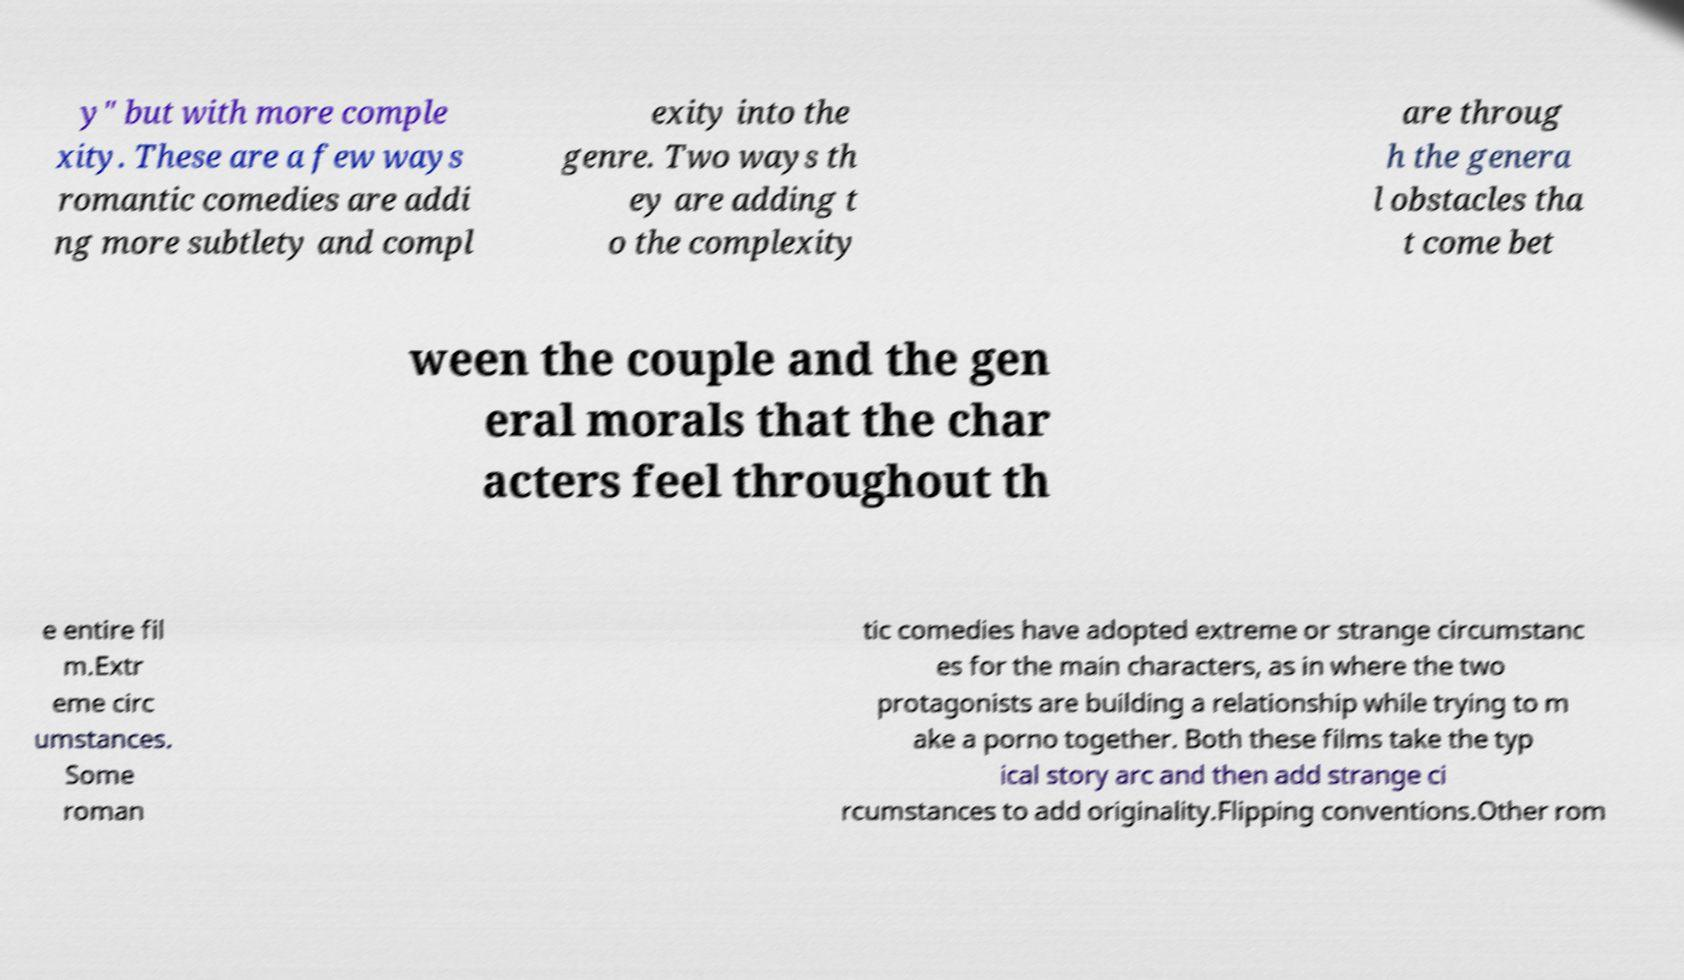Please identify and transcribe the text found in this image. y" but with more comple xity. These are a few ways romantic comedies are addi ng more subtlety and compl exity into the genre. Two ways th ey are adding t o the complexity are throug h the genera l obstacles tha t come bet ween the couple and the gen eral morals that the char acters feel throughout th e entire fil m.Extr eme circ umstances. Some roman tic comedies have adopted extreme or strange circumstanc es for the main characters, as in where the two protagonists are building a relationship while trying to m ake a porno together. Both these films take the typ ical story arc and then add strange ci rcumstances to add originality.Flipping conventions.Other rom 